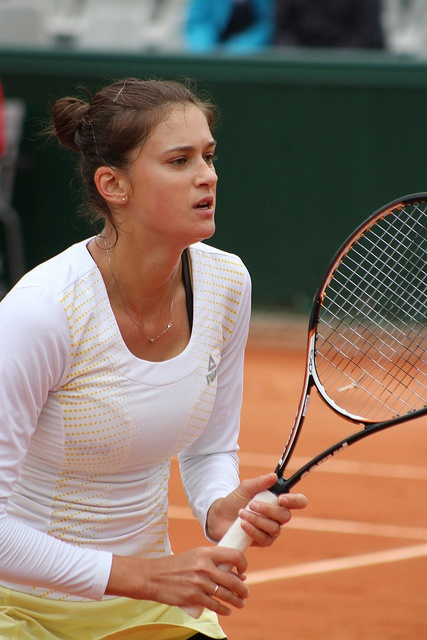Describe the objects in this image and their specific colors. I can see people in darkgray, lavender, and brown tones and tennis racket in darkgray, black, tan, brown, and gray tones in this image. 